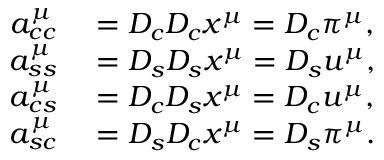Convert formula to latex. <formula><loc_0><loc_0><loc_500><loc_500>\begin{array} { r l } { a _ { c c } ^ { \mu } } & = D _ { c } D _ { c } x ^ { \mu } = D _ { c } \pi ^ { \mu } , } \\ { a _ { s s } ^ { \mu } } & = D _ { s } D _ { s } x ^ { \mu } = D _ { s } u ^ { \mu } , } \\ { a _ { c s } ^ { \mu } } & = D _ { c } D _ { s } x ^ { \mu } = D _ { c } u ^ { \mu } , } \\ { a _ { s c } ^ { \mu } } & = D _ { s } D _ { c } x ^ { \mu } = D _ { s } \pi ^ { \mu } . } \end{array}</formula> 